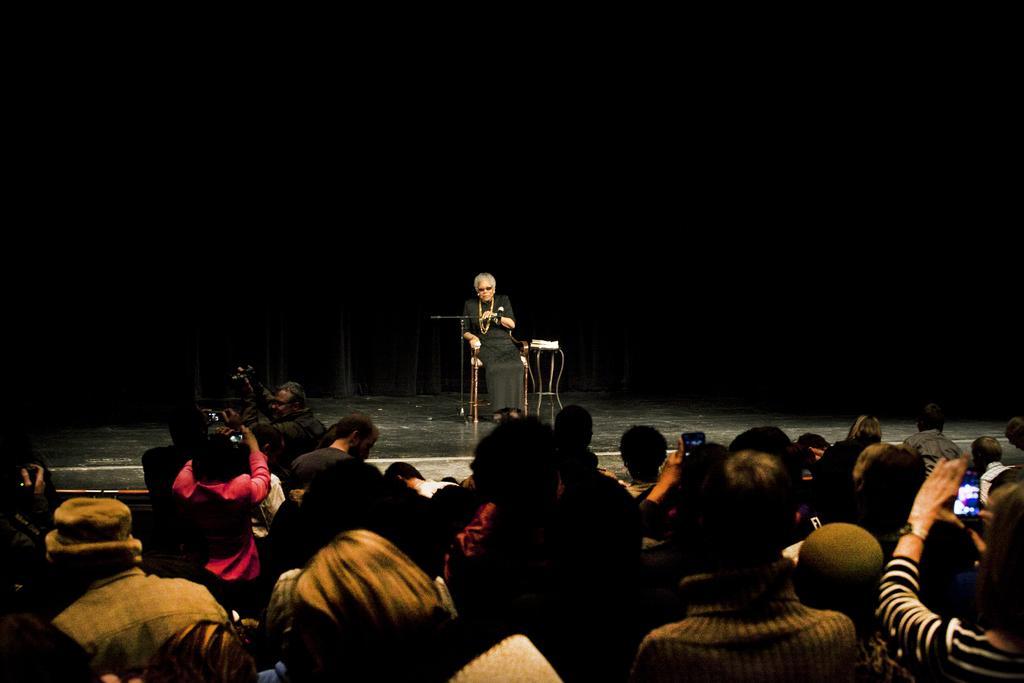Could you give a brief overview of what you see in this image? In this image we can see there is an old man on the stage sitting on the chair. 